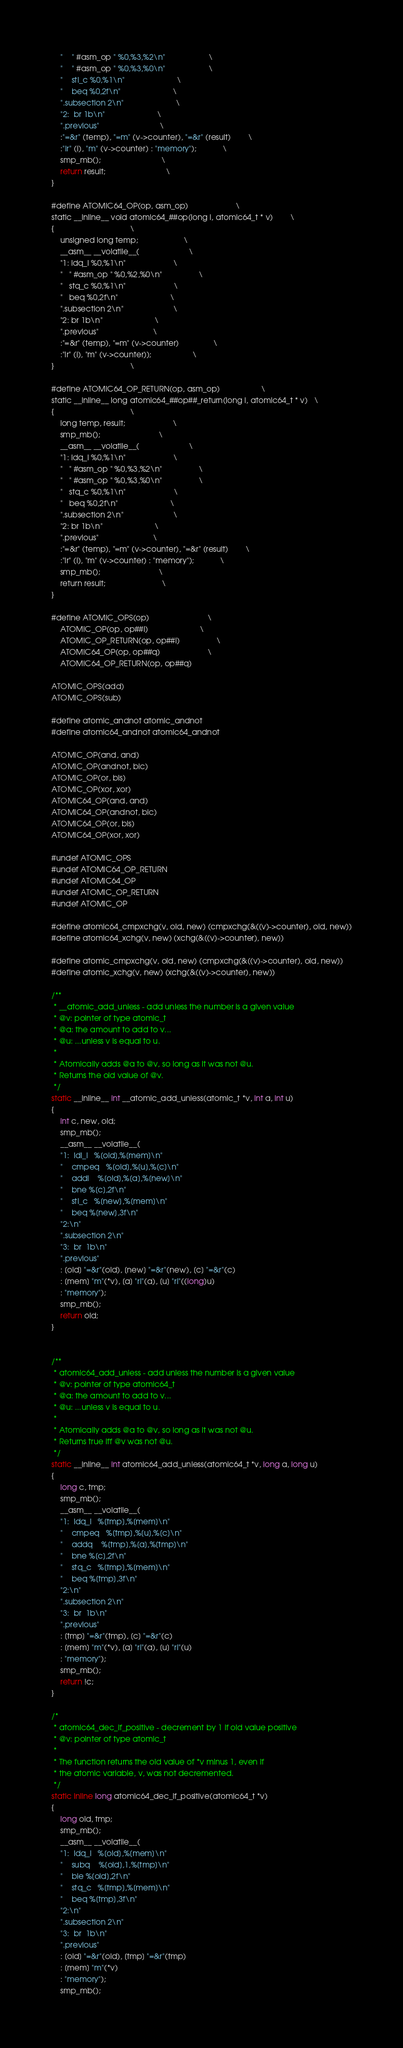<code> <loc_0><loc_0><loc_500><loc_500><_C_>	"	" #asm_op " %0,%3,%2\n"					\
	"	" #asm_op " %0,%3,%0\n"					\
	"	stl_c %0,%1\n"						\
	"	beq %0,2f\n"						\
	".subsection 2\n"						\
	"2:	br 1b\n"						\
	".previous"							\
	:"=&r" (temp), "=m" (v->counter), "=&r" (result)		\
	:"Ir" (i), "m" (v->counter) : "memory");			\
	smp_mb();							\
	return result;							\
}

#define ATOMIC64_OP(op, asm_op)						\
static __inline__ void atomic64_##op(long i, atomic64_t * v)		\
{									\
	unsigned long temp;						\
	__asm__ __volatile__(						\
	"1:	ldq_l %0,%1\n"						\
	"	" #asm_op " %0,%2,%0\n"					\
	"	stq_c %0,%1\n"						\
	"	beq %0,2f\n"						\
	".subsection 2\n"						\
	"2:	br 1b\n"						\
	".previous"							\
	:"=&r" (temp), "=m" (v->counter)				\
	:"Ir" (i), "m" (v->counter));					\
}									\

#define ATOMIC64_OP_RETURN(op, asm_op)					\
static __inline__ long atomic64_##op##_return(long i, atomic64_t * v)	\
{									\
	long temp, result;						\
	smp_mb();							\
	__asm__ __volatile__(						\
	"1:	ldq_l %0,%1\n"						\
	"	" #asm_op " %0,%3,%2\n"					\
	"	" #asm_op " %0,%3,%0\n"					\
	"	stq_c %0,%1\n"						\
	"	beq %0,2f\n"						\
	".subsection 2\n"						\
	"2:	br 1b\n"						\
	".previous"							\
	:"=&r" (temp), "=m" (v->counter), "=&r" (result)		\
	:"Ir" (i), "m" (v->counter) : "memory");			\
	smp_mb();							\
	return result;							\
}

#define ATOMIC_OPS(op)							\
	ATOMIC_OP(op, op##l)						\
	ATOMIC_OP_RETURN(op, op##l)					\
	ATOMIC64_OP(op, op##q)						\
	ATOMIC64_OP_RETURN(op, op##q)

ATOMIC_OPS(add)
ATOMIC_OPS(sub)

#define atomic_andnot atomic_andnot
#define atomic64_andnot atomic64_andnot

ATOMIC_OP(and, and)
ATOMIC_OP(andnot, bic)
ATOMIC_OP(or, bis)
ATOMIC_OP(xor, xor)
ATOMIC64_OP(and, and)
ATOMIC64_OP(andnot, bic)
ATOMIC64_OP(or, bis)
ATOMIC64_OP(xor, xor)

#undef ATOMIC_OPS
#undef ATOMIC64_OP_RETURN
#undef ATOMIC64_OP
#undef ATOMIC_OP_RETURN
#undef ATOMIC_OP

#define atomic64_cmpxchg(v, old, new) (cmpxchg(&((v)->counter), old, new))
#define atomic64_xchg(v, new) (xchg(&((v)->counter), new))

#define atomic_cmpxchg(v, old, new) (cmpxchg(&((v)->counter), old, new))
#define atomic_xchg(v, new) (xchg(&((v)->counter), new))

/**
 * __atomic_add_unless - add unless the number is a given value
 * @v: pointer of type atomic_t
 * @a: the amount to add to v...
 * @u: ...unless v is equal to u.
 *
 * Atomically adds @a to @v, so long as it was not @u.
 * Returns the old value of @v.
 */
static __inline__ int __atomic_add_unless(atomic_t *v, int a, int u)
{
	int c, new, old;
	smp_mb();
	__asm__ __volatile__(
	"1:	ldl_l	%[old],%[mem]\n"
	"	cmpeq	%[old],%[u],%[c]\n"
	"	addl	%[old],%[a],%[new]\n"
	"	bne	%[c],2f\n"
	"	stl_c	%[new],%[mem]\n"
	"	beq	%[new],3f\n"
	"2:\n"
	".subsection 2\n"
	"3:	br	1b\n"
	".previous"
	: [old] "=&r"(old), [new] "=&r"(new), [c] "=&r"(c)
	: [mem] "m"(*v), [a] "rI"(a), [u] "rI"((long)u)
	: "memory");
	smp_mb();
	return old;
}


/**
 * atomic64_add_unless - add unless the number is a given value
 * @v: pointer of type atomic64_t
 * @a: the amount to add to v...
 * @u: ...unless v is equal to u.
 *
 * Atomically adds @a to @v, so long as it was not @u.
 * Returns true iff @v was not @u.
 */
static __inline__ int atomic64_add_unless(atomic64_t *v, long a, long u)
{
	long c, tmp;
	smp_mb();
	__asm__ __volatile__(
	"1:	ldq_l	%[tmp],%[mem]\n"
	"	cmpeq	%[tmp],%[u],%[c]\n"
	"	addq	%[tmp],%[a],%[tmp]\n"
	"	bne	%[c],2f\n"
	"	stq_c	%[tmp],%[mem]\n"
	"	beq	%[tmp],3f\n"
	"2:\n"
	".subsection 2\n"
	"3:	br	1b\n"
	".previous"
	: [tmp] "=&r"(tmp), [c] "=&r"(c)
	: [mem] "m"(*v), [a] "rI"(a), [u] "rI"(u)
	: "memory");
	smp_mb();
	return !c;
}

/*
 * atomic64_dec_if_positive - decrement by 1 if old value positive
 * @v: pointer of type atomic_t
 *
 * The function returns the old value of *v minus 1, even if
 * the atomic variable, v, was not decremented.
 */
static inline long atomic64_dec_if_positive(atomic64_t *v)
{
	long old, tmp;
	smp_mb();
	__asm__ __volatile__(
	"1:	ldq_l	%[old],%[mem]\n"
	"	subq	%[old],1,%[tmp]\n"
	"	ble	%[old],2f\n"
	"	stq_c	%[tmp],%[mem]\n"
	"	beq	%[tmp],3f\n"
	"2:\n"
	".subsection 2\n"
	"3:	br	1b\n"
	".previous"
	: [old] "=&r"(old), [tmp] "=&r"(tmp)
	: [mem] "m"(*v)
	: "memory");
	smp_mb();</code> 